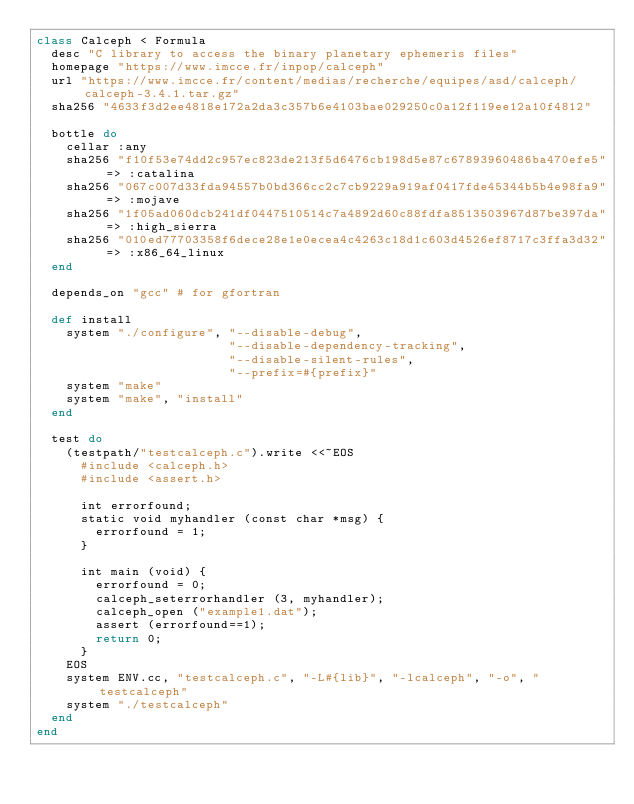<code> <loc_0><loc_0><loc_500><loc_500><_Ruby_>class Calceph < Formula
  desc "C library to access the binary planetary ephemeris files"
  homepage "https://www.imcce.fr/inpop/calceph"
  url "https://www.imcce.fr/content/medias/recherche/equipes/asd/calceph/calceph-3.4.1.tar.gz"
  sha256 "4633f3d2ee4818e172a2da3c357b6e4103bae029250c0a12f119ee12a10f4812"

  bottle do
    cellar :any
    sha256 "f10f53e74dd2c957ec823de213f5d6476cb198d5e87c67893960486ba470efe5" => :catalina
    sha256 "067c007d33fda94557b0bd366cc2c7cb9229a919af0417fde45344b5b4e98fa9" => :mojave
    sha256 "1f05ad060dcb241df0447510514c7a4892d60c88fdfa8513503967d87be397da" => :high_sierra
    sha256 "010ed77703358f6dece28e1e0ecea4c4263c18d1c603d4526ef8717c3ffa3d32" => :x86_64_linux
  end

  depends_on "gcc" # for gfortran

  def install
    system "./configure", "--disable-debug",
                          "--disable-dependency-tracking",
                          "--disable-silent-rules",
                          "--prefix=#{prefix}"
    system "make"
    system "make", "install"
  end

  test do
    (testpath/"testcalceph.c").write <<~EOS
      #include <calceph.h>
      #include <assert.h>

      int errorfound;
      static void myhandler (const char *msg) {
        errorfound = 1;
      }

      int main (void) {
        errorfound = 0;
        calceph_seterrorhandler (3, myhandler);
        calceph_open ("example1.dat");
        assert (errorfound==1);
        return 0;
      }
    EOS
    system ENV.cc, "testcalceph.c", "-L#{lib}", "-lcalceph", "-o", "testcalceph"
    system "./testcalceph"
  end
end
</code> 